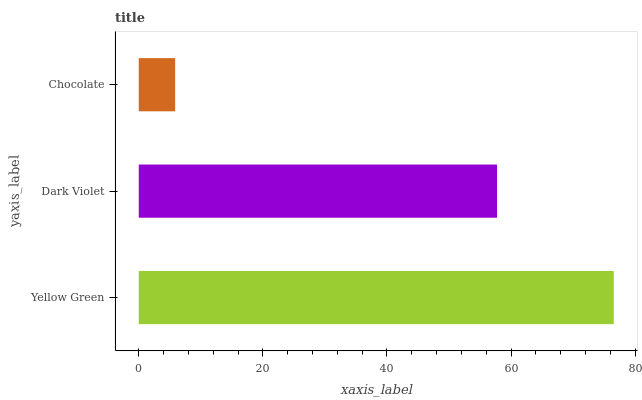Is Chocolate the minimum?
Answer yes or no. Yes. Is Yellow Green the maximum?
Answer yes or no. Yes. Is Dark Violet the minimum?
Answer yes or no. No. Is Dark Violet the maximum?
Answer yes or no. No. Is Yellow Green greater than Dark Violet?
Answer yes or no. Yes. Is Dark Violet less than Yellow Green?
Answer yes or no. Yes. Is Dark Violet greater than Yellow Green?
Answer yes or no. No. Is Yellow Green less than Dark Violet?
Answer yes or no. No. Is Dark Violet the high median?
Answer yes or no. Yes. Is Dark Violet the low median?
Answer yes or no. Yes. Is Yellow Green the high median?
Answer yes or no. No. Is Yellow Green the low median?
Answer yes or no. No. 